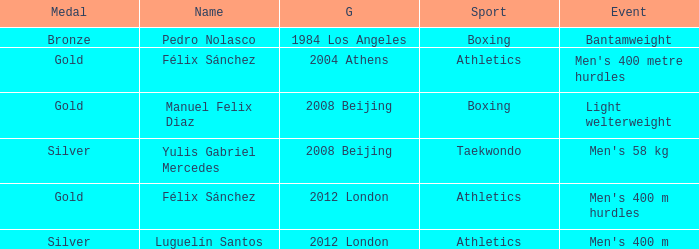Which Sport had an Event of men's 400 m hurdles? Athletics. 